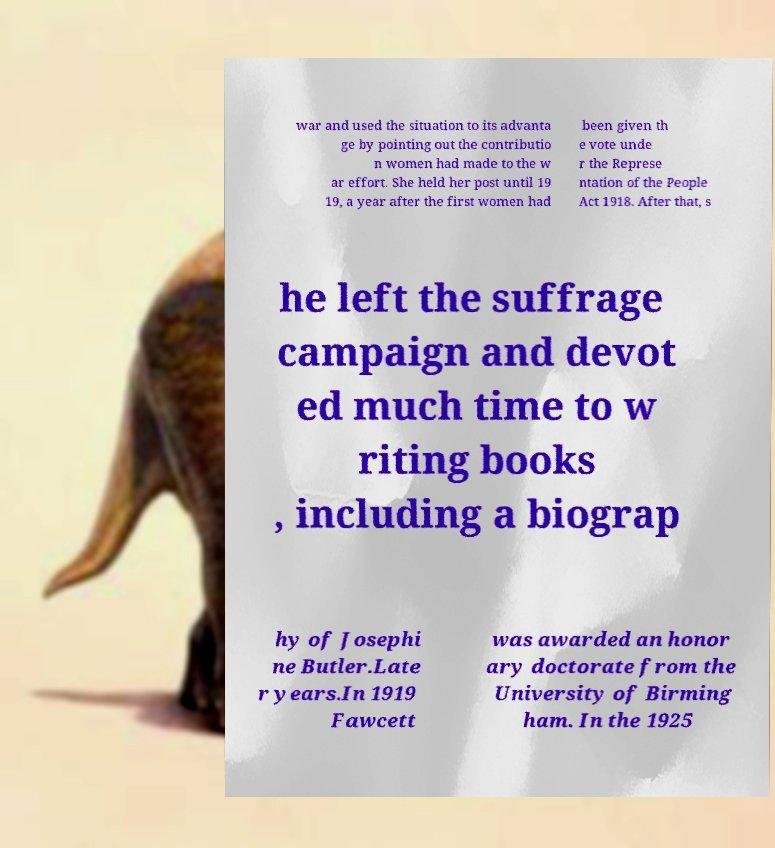Can you read and provide the text displayed in the image?This photo seems to have some interesting text. Can you extract and type it out for me? war and used the situation to its advanta ge by pointing out the contributio n women had made to the w ar effort. She held her post until 19 19, a year after the first women had been given th e vote unde r the Represe ntation of the People Act 1918. After that, s he left the suffrage campaign and devot ed much time to w riting books , including a biograp hy of Josephi ne Butler.Late r years.In 1919 Fawcett was awarded an honor ary doctorate from the University of Birming ham. In the 1925 